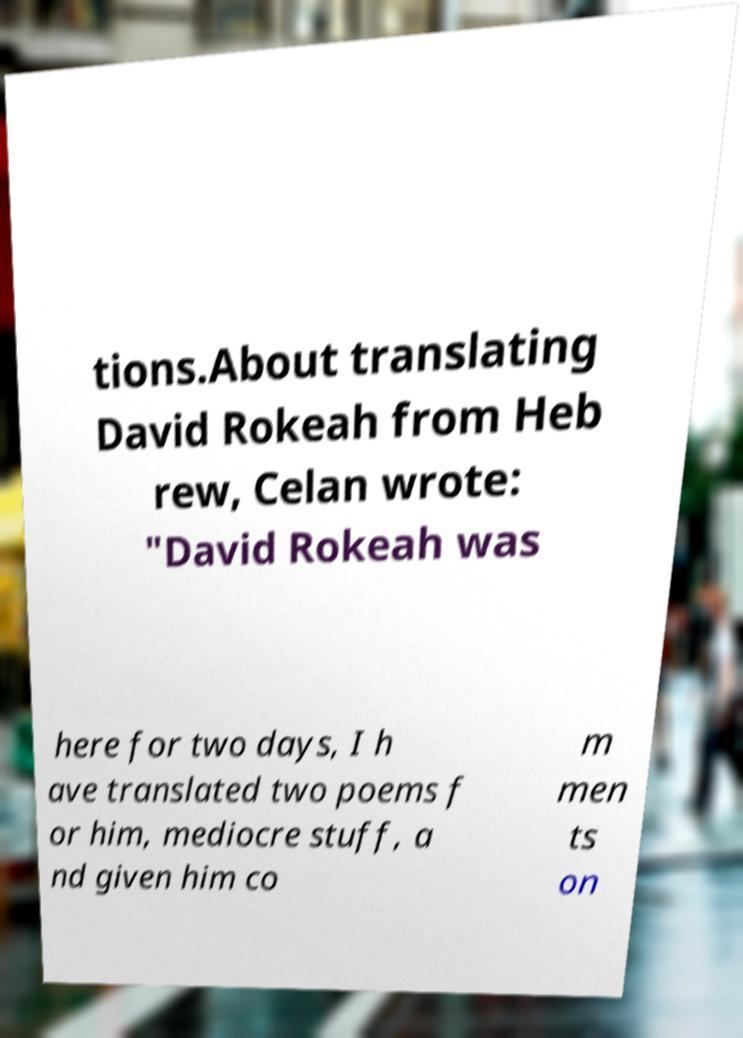There's text embedded in this image that I need extracted. Can you transcribe it verbatim? tions.About translating David Rokeah from Heb rew, Celan wrote: "David Rokeah was here for two days, I h ave translated two poems f or him, mediocre stuff, a nd given him co m men ts on 